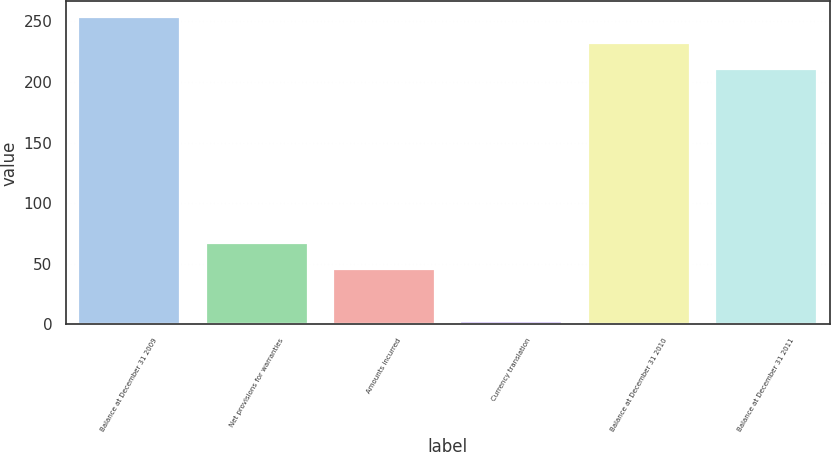Convert chart. <chart><loc_0><loc_0><loc_500><loc_500><bar_chart><fcel>Balance at December 31 2009<fcel>Net provisions for warranties<fcel>Amounts incurred<fcel>Currency translation<fcel>Balance at December 31 2010<fcel>Balance at December 31 2011<nl><fcel>253.8<fcel>67.2<fcel>45.8<fcel>3<fcel>232.4<fcel>211<nl></chart> 